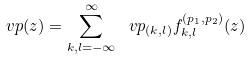Convert formula to latex. <formula><loc_0><loc_0><loc_500><loc_500>\ v p ( z ) = \sum _ { k , l = - \infty } ^ { \infty } \, \ v p _ { ( k , l ) } f ^ { ( p _ { 1 } , p _ { 2 } ) } _ { k , l } ( z )</formula> 